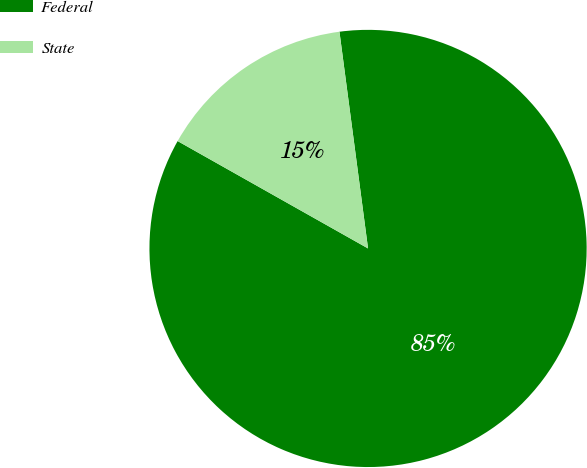Convert chart to OTSL. <chart><loc_0><loc_0><loc_500><loc_500><pie_chart><fcel>Federal<fcel>State<nl><fcel>85.26%<fcel>14.74%<nl></chart> 